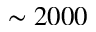<formula> <loc_0><loc_0><loc_500><loc_500>\sim 2 0 0 0</formula> 